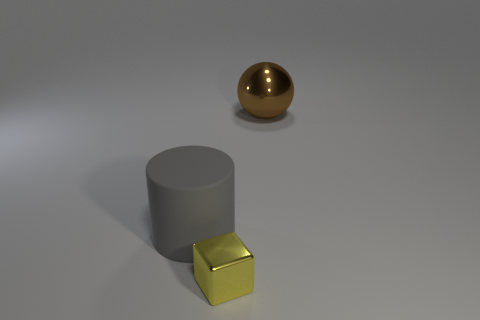Add 1 small gray cylinders. How many objects exist? 4 Subtract 1 gray cylinders. How many objects are left? 2 Subtract all cylinders. How many objects are left? 2 Subtract 1 cubes. How many cubes are left? 0 Subtract all gray cubes. Subtract all yellow spheres. How many cubes are left? 1 Subtract all gray cylinders. How many red blocks are left? 0 Subtract all large gray cylinders. Subtract all yellow metal objects. How many objects are left? 1 Add 1 large gray cylinders. How many large gray cylinders are left? 2 Add 3 gray cylinders. How many gray cylinders exist? 4 